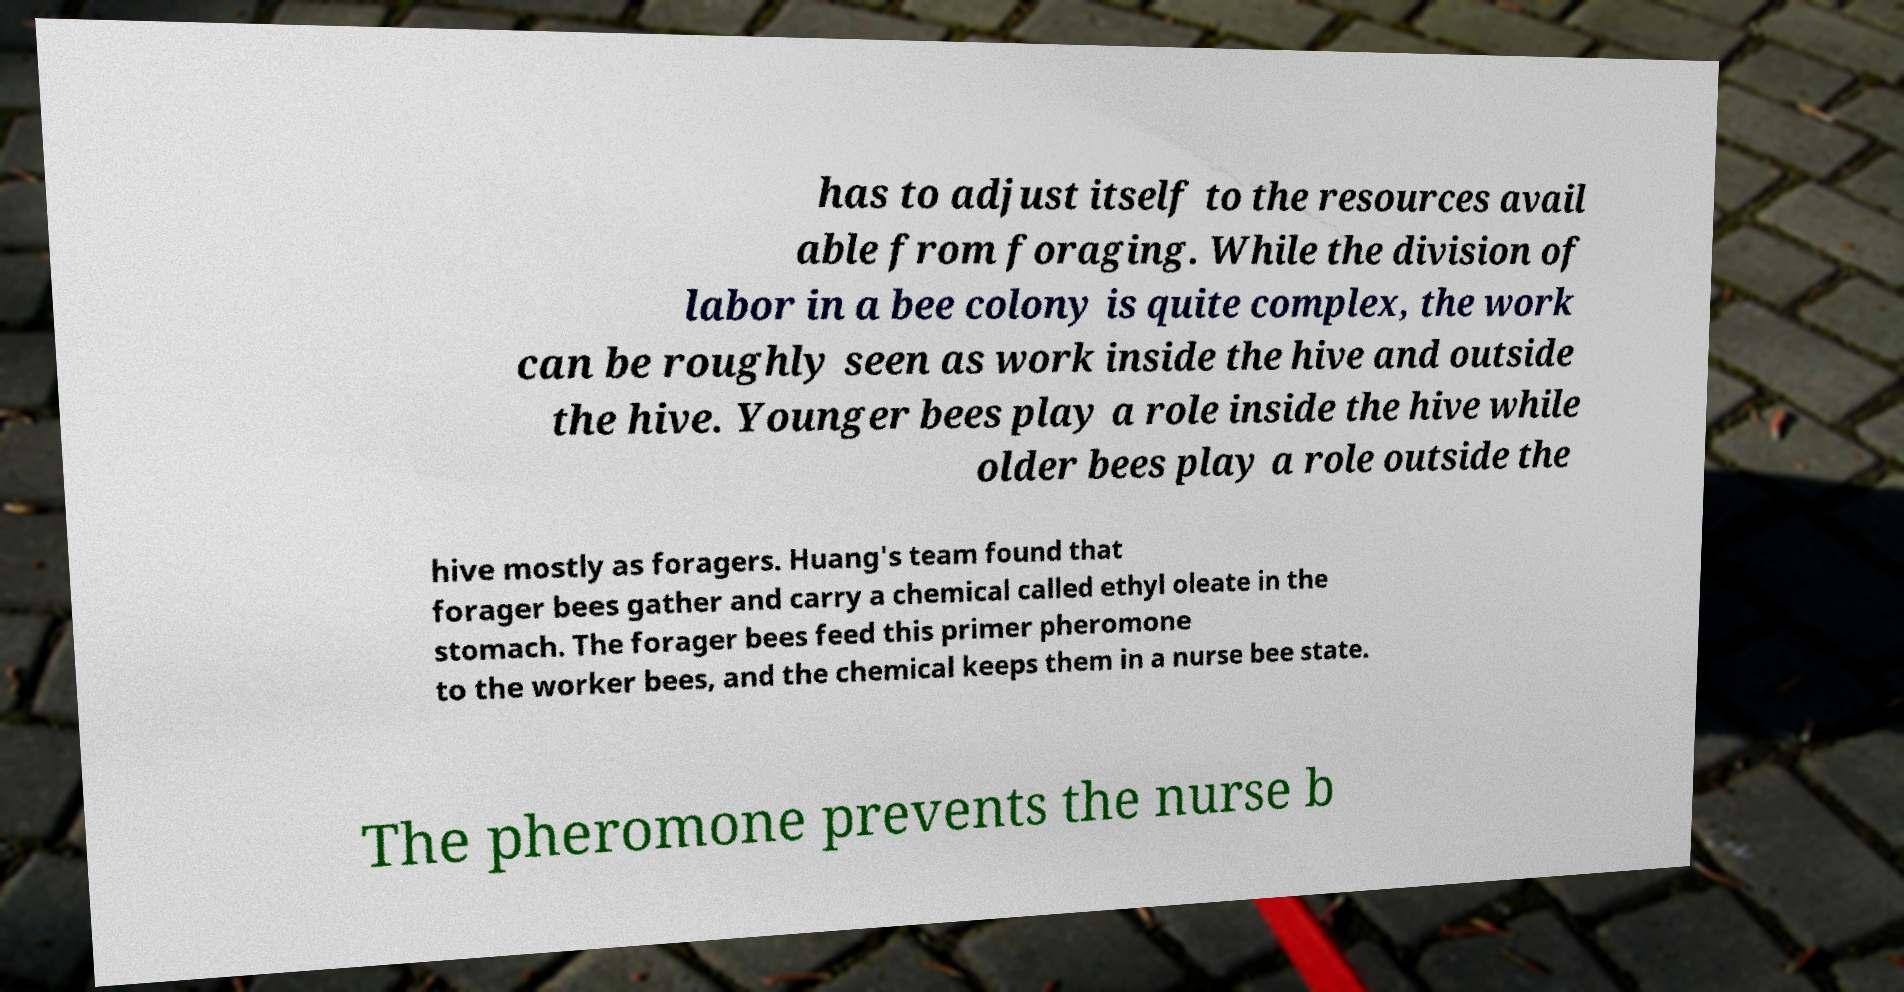What messages or text are displayed in this image? I need them in a readable, typed format. has to adjust itself to the resources avail able from foraging. While the division of labor in a bee colony is quite complex, the work can be roughly seen as work inside the hive and outside the hive. Younger bees play a role inside the hive while older bees play a role outside the hive mostly as foragers. Huang's team found that forager bees gather and carry a chemical called ethyl oleate in the stomach. The forager bees feed this primer pheromone to the worker bees, and the chemical keeps them in a nurse bee state. The pheromone prevents the nurse b 